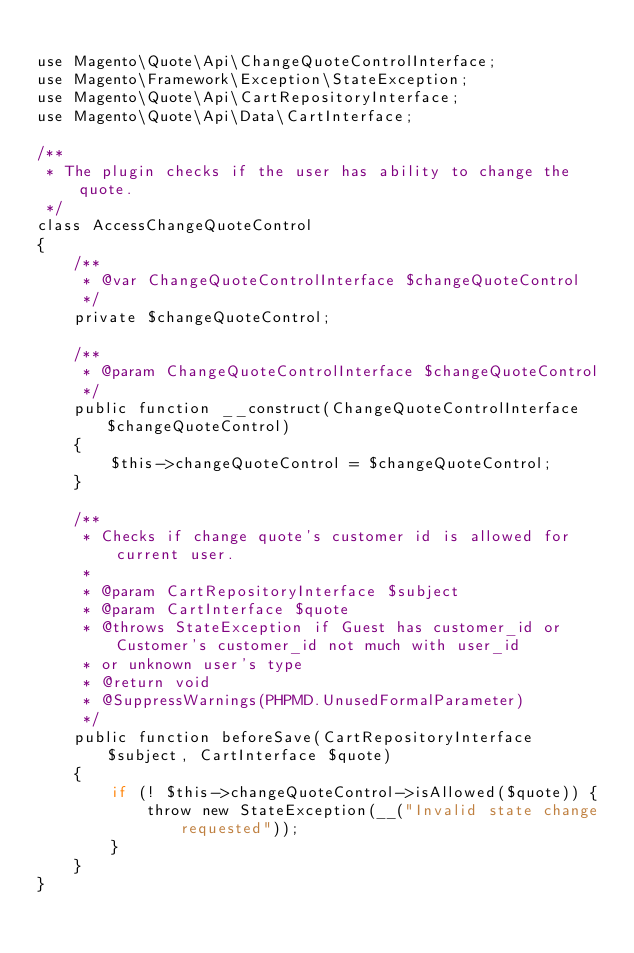<code> <loc_0><loc_0><loc_500><loc_500><_PHP_>
use Magento\Quote\Api\ChangeQuoteControlInterface;
use Magento\Framework\Exception\StateException;
use Magento\Quote\Api\CartRepositoryInterface;
use Magento\Quote\Api\Data\CartInterface;

/**
 * The plugin checks if the user has ability to change the quote.
 */
class AccessChangeQuoteControl
{
    /**
     * @var ChangeQuoteControlInterface $changeQuoteControl
     */
    private $changeQuoteControl;

    /**
     * @param ChangeQuoteControlInterface $changeQuoteControl
     */
    public function __construct(ChangeQuoteControlInterface $changeQuoteControl)
    {
        $this->changeQuoteControl = $changeQuoteControl;
    }

    /**
     * Checks if change quote's customer id is allowed for current user.
     *
     * @param CartRepositoryInterface $subject
     * @param CartInterface $quote
     * @throws StateException if Guest has customer_id or Customer's customer_id not much with user_id
     * or unknown user's type
     * @return void
     * @SuppressWarnings(PHPMD.UnusedFormalParameter)
     */
    public function beforeSave(CartRepositoryInterface $subject, CartInterface $quote)
    {
        if (! $this->changeQuoteControl->isAllowed($quote)) {
            throw new StateException(__("Invalid state change requested"));
        }
    }
}
</code> 